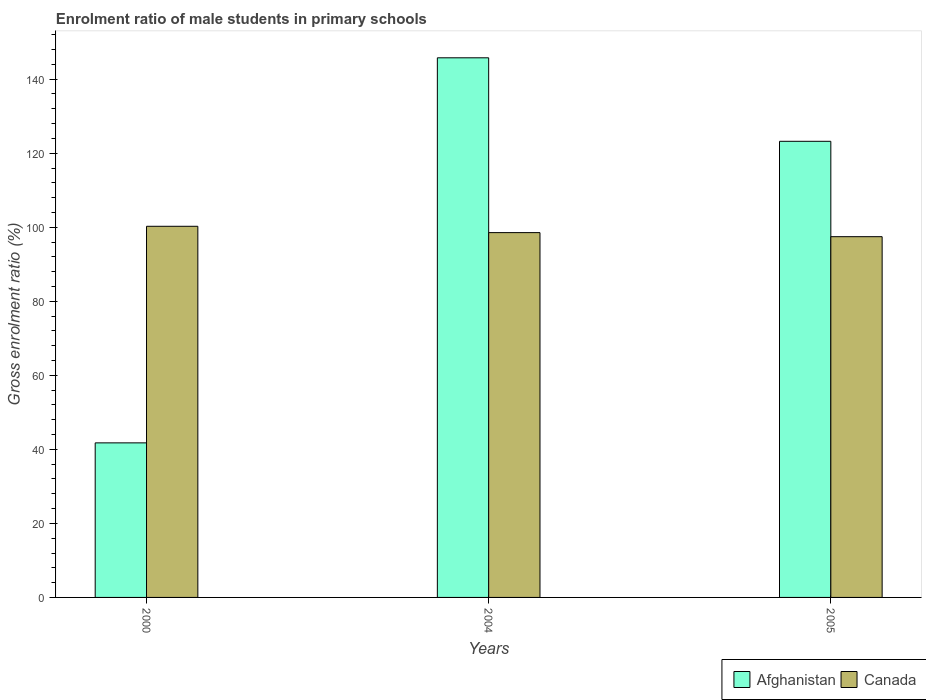How many different coloured bars are there?
Provide a succinct answer. 2. Are the number of bars per tick equal to the number of legend labels?
Give a very brief answer. Yes. How many bars are there on the 1st tick from the right?
Ensure brevity in your answer.  2. In how many cases, is the number of bars for a given year not equal to the number of legend labels?
Offer a very short reply. 0. What is the enrolment ratio of male students in primary schools in Canada in 2005?
Your response must be concise. 97.45. Across all years, what is the maximum enrolment ratio of male students in primary schools in Canada?
Your answer should be compact. 100.26. Across all years, what is the minimum enrolment ratio of male students in primary schools in Canada?
Make the answer very short. 97.45. In which year was the enrolment ratio of male students in primary schools in Canada maximum?
Give a very brief answer. 2000. In which year was the enrolment ratio of male students in primary schools in Afghanistan minimum?
Provide a succinct answer. 2000. What is the total enrolment ratio of male students in primary schools in Canada in the graph?
Your answer should be very brief. 296.26. What is the difference between the enrolment ratio of male students in primary schools in Afghanistan in 2000 and that in 2004?
Your response must be concise. -104.02. What is the difference between the enrolment ratio of male students in primary schools in Afghanistan in 2000 and the enrolment ratio of male students in primary schools in Canada in 2005?
Offer a terse response. -55.7. What is the average enrolment ratio of male students in primary schools in Canada per year?
Offer a very short reply. 98.75. In the year 2004, what is the difference between the enrolment ratio of male students in primary schools in Canada and enrolment ratio of male students in primary schools in Afghanistan?
Make the answer very short. -47.22. In how many years, is the enrolment ratio of male students in primary schools in Afghanistan greater than 4 %?
Offer a terse response. 3. What is the ratio of the enrolment ratio of male students in primary schools in Afghanistan in 2000 to that in 2004?
Ensure brevity in your answer.  0.29. Is the enrolment ratio of male students in primary schools in Afghanistan in 2000 less than that in 2004?
Provide a short and direct response. Yes. Is the difference between the enrolment ratio of male students in primary schools in Canada in 2004 and 2005 greater than the difference between the enrolment ratio of male students in primary schools in Afghanistan in 2004 and 2005?
Provide a succinct answer. No. What is the difference between the highest and the second highest enrolment ratio of male students in primary schools in Afghanistan?
Provide a short and direct response. 22.56. What is the difference between the highest and the lowest enrolment ratio of male students in primary schools in Canada?
Your answer should be compact. 2.81. In how many years, is the enrolment ratio of male students in primary schools in Canada greater than the average enrolment ratio of male students in primary schools in Canada taken over all years?
Provide a short and direct response. 1. Is the sum of the enrolment ratio of male students in primary schools in Afghanistan in 2004 and 2005 greater than the maximum enrolment ratio of male students in primary schools in Canada across all years?
Your response must be concise. Yes. What does the 1st bar from the left in 2004 represents?
Offer a very short reply. Afghanistan. What does the 1st bar from the right in 2005 represents?
Provide a short and direct response. Canada. How many bars are there?
Your response must be concise. 6. Are the values on the major ticks of Y-axis written in scientific E-notation?
Your response must be concise. No. Does the graph contain any zero values?
Give a very brief answer. No. Does the graph contain grids?
Your answer should be very brief. No. How many legend labels are there?
Ensure brevity in your answer.  2. How are the legend labels stacked?
Your answer should be very brief. Horizontal. What is the title of the graph?
Your answer should be compact. Enrolment ratio of male students in primary schools. What is the label or title of the X-axis?
Your answer should be compact. Years. What is the Gross enrolment ratio (%) of Afghanistan in 2000?
Offer a very short reply. 41.75. What is the Gross enrolment ratio (%) in Canada in 2000?
Keep it short and to the point. 100.26. What is the Gross enrolment ratio (%) in Afghanistan in 2004?
Keep it short and to the point. 145.77. What is the Gross enrolment ratio (%) of Canada in 2004?
Provide a succinct answer. 98.55. What is the Gross enrolment ratio (%) of Afghanistan in 2005?
Offer a very short reply. 123.21. What is the Gross enrolment ratio (%) of Canada in 2005?
Your response must be concise. 97.45. Across all years, what is the maximum Gross enrolment ratio (%) of Afghanistan?
Provide a short and direct response. 145.77. Across all years, what is the maximum Gross enrolment ratio (%) in Canada?
Give a very brief answer. 100.26. Across all years, what is the minimum Gross enrolment ratio (%) of Afghanistan?
Your answer should be very brief. 41.75. Across all years, what is the minimum Gross enrolment ratio (%) of Canada?
Give a very brief answer. 97.45. What is the total Gross enrolment ratio (%) in Afghanistan in the graph?
Keep it short and to the point. 310.74. What is the total Gross enrolment ratio (%) in Canada in the graph?
Give a very brief answer. 296.26. What is the difference between the Gross enrolment ratio (%) of Afghanistan in 2000 and that in 2004?
Keep it short and to the point. -104.02. What is the difference between the Gross enrolment ratio (%) in Canada in 2000 and that in 2004?
Keep it short and to the point. 1.71. What is the difference between the Gross enrolment ratio (%) of Afghanistan in 2000 and that in 2005?
Ensure brevity in your answer.  -81.46. What is the difference between the Gross enrolment ratio (%) in Canada in 2000 and that in 2005?
Provide a short and direct response. 2.81. What is the difference between the Gross enrolment ratio (%) in Afghanistan in 2004 and that in 2005?
Offer a very short reply. 22.56. What is the difference between the Gross enrolment ratio (%) in Canada in 2004 and that in 2005?
Offer a very short reply. 1.1. What is the difference between the Gross enrolment ratio (%) of Afghanistan in 2000 and the Gross enrolment ratio (%) of Canada in 2004?
Offer a very short reply. -56.8. What is the difference between the Gross enrolment ratio (%) in Afghanistan in 2000 and the Gross enrolment ratio (%) in Canada in 2005?
Keep it short and to the point. -55.7. What is the difference between the Gross enrolment ratio (%) of Afghanistan in 2004 and the Gross enrolment ratio (%) of Canada in 2005?
Make the answer very short. 48.32. What is the average Gross enrolment ratio (%) of Afghanistan per year?
Provide a succinct answer. 103.58. What is the average Gross enrolment ratio (%) in Canada per year?
Give a very brief answer. 98.75. In the year 2000, what is the difference between the Gross enrolment ratio (%) in Afghanistan and Gross enrolment ratio (%) in Canada?
Keep it short and to the point. -58.51. In the year 2004, what is the difference between the Gross enrolment ratio (%) of Afghanistan and Gross enrolment ratio (%) of Canada?
Keep it short and to the point. 47.22. In the year 2005, what is the difference between the Gross enrolment ratio (%) in Afghanistan and Gross enrolment ratio (%) in Canada?
Your answer should be compact. 25.76. What is the ratio of the Gross enrolment ratio (%) of Afghanistan in 2000 to that in 2004?
Provide a succinct answer. 0.29. What is the ratio of the Gross enrolment ratio (%) in Canada in 2000 to that in 2004?
Make the answer very short. 1.02. What is the ratio of the Gross enrolment ratio (%) of Afghanistan in 2000 to that in 2005?
Your answer should be very brief. 0.34. What is the ratio of the Gross enrolment ratio (%) in Canada in 2000 to that in 2005?
Provide a succinct answer. 1.03. What is the ratio of the Gross enrolment ratio (%) of Afghanistan in 2004 to that in 2005?
Give a very brief answer. 1.18. What is the ratio of the Gross enrolment ratio (%) of Canada in 2004 to that in 2005?
Provide a succinct answer. 1.01. What is the difference between the highest and the second highest Gross enrolment ratio (%) in Afghanistan?
Provide a short and direct response. 22.56. What is the difference between the highest and the second highest Gross enrolment ratio (%) in Canada?
Your answer should be compact. 1.71. What is the difference between the highest and the lowest Gross enrolment ratio (%) in Afghanistan?
Provide a succinct answer. 104.02. What is the difference between the highest and the lowest Gross enrolment ratio (%) in Canada?
Offer a very short reply. 2.81. 